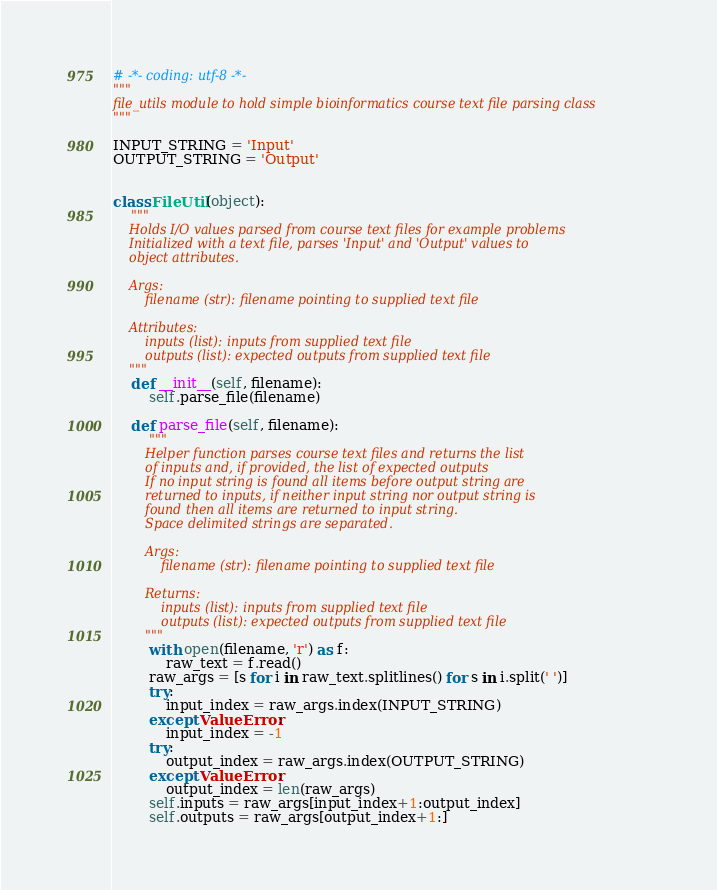Convert code to text. <code><loc_0><loc_0><loc_500><loc_500><_Python_># -*- coding: utf-8 -*-
"""
file_utils module to hold simple bioinformatics course text file parsing class
"""

INPUT_STRING = 'Input'
OUTPUT_STRING = 'Output'


class FileUtil(object):
    """
    Holds I/O values parsed from course text files for example problems
    Initialized with a text file, parses 'Input' and 'Output' values to
    object attributes.

    Args:
        filename (str): filename pointing to supplied text file

    Attributes:
        inputs (list): inputs from supplied text file
        outputs (list): expected outputs from supplied text file
    """
    def __init__(self, filename):
        self.parse_file(filename)

    def parse_file(self, filename):
        """
        Helper function parses course text files and returns the list
        of inputs and, if provided, the list of expected outputs
        If no input string is found all items before output string are
        returned to inputs, if neither input string nor output string is
        found then all items are returned to input string.
        Space delimited strings are separated.

        Args:
            filename (str): filename pointing to supplied text file

        Returns:
            inputs (list): inputs from supplied text file
            outputs (list): expected outputs from supplied text file
        """
        with open(filename, 'r') as f:
            raw_text = f.read()
        raw_args = [s for i in raw_text.splitlines() for s in i.split(' ')]
        try:
            input_index = raw_args.index(INPUT_STRING)
        except ValueError:
            input_index = -1
        try:
            output_index = raw_args.index(OUTPUT_STRING)
        except ValueError:
            output_index = len(raw_args)
        self.inputs = raw_args[input_index+1:output_index]
        self.outputs = raw_args[output_index+1:]
</code> 